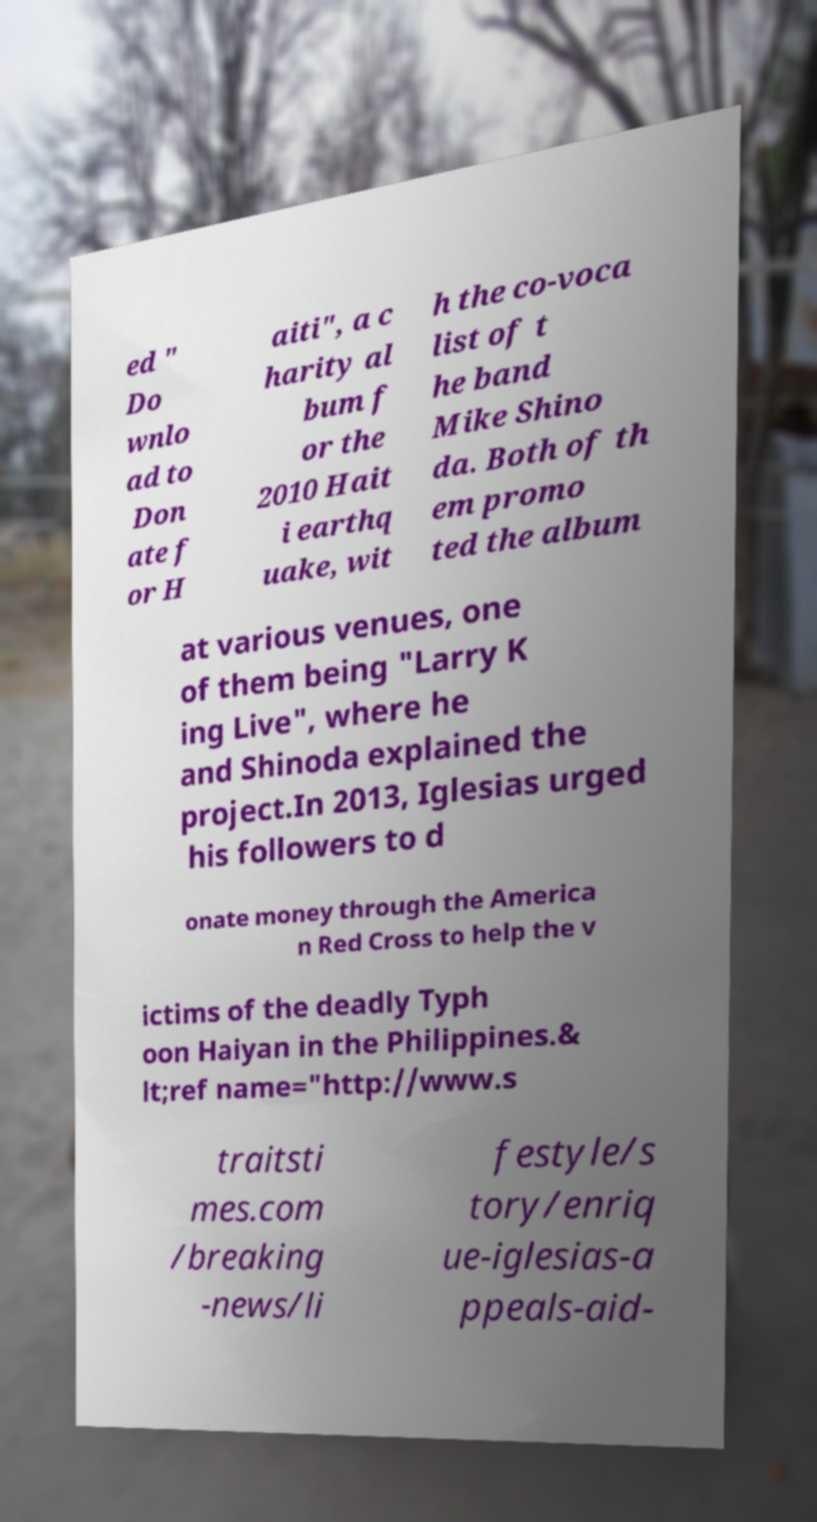Can you accurately transcribe the text from the provided image for me? ed " Do wnlo ad to Don ate f or H aiti", a c harity al bum f or the 2010 Hait i earthq uake, wit h the co-voca list of t he band Mike Shino da. Both of th em promo ted the album at various venues, one of them being "Larry K ing Live", where he and Shinoda explained the project.In 2013, Iglesias urged his followers to d onate money through the America n Red Cross to help the v ictims of the deadly Typh oon Haiyan in the Philippines.& lt;ref name="http://www.s traitsti mes.com /breaking -news/li festyle/s tory/enriq ue-iglesias-a ppeals-aid- 